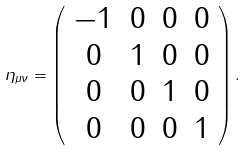<formula> <loc_0><loc_0><loc_500><loc_500>\eta _ { \mu \nu } = \left ( \begin{array} { c c c c } - 1 & 0 & 0 & 0 \\ 0 & 1 & 0 & 0 \\ 0 & 0 & 1 & 0 \\ 0 & 0 & 0 & 1 \end{array} \right ) .</formula> 